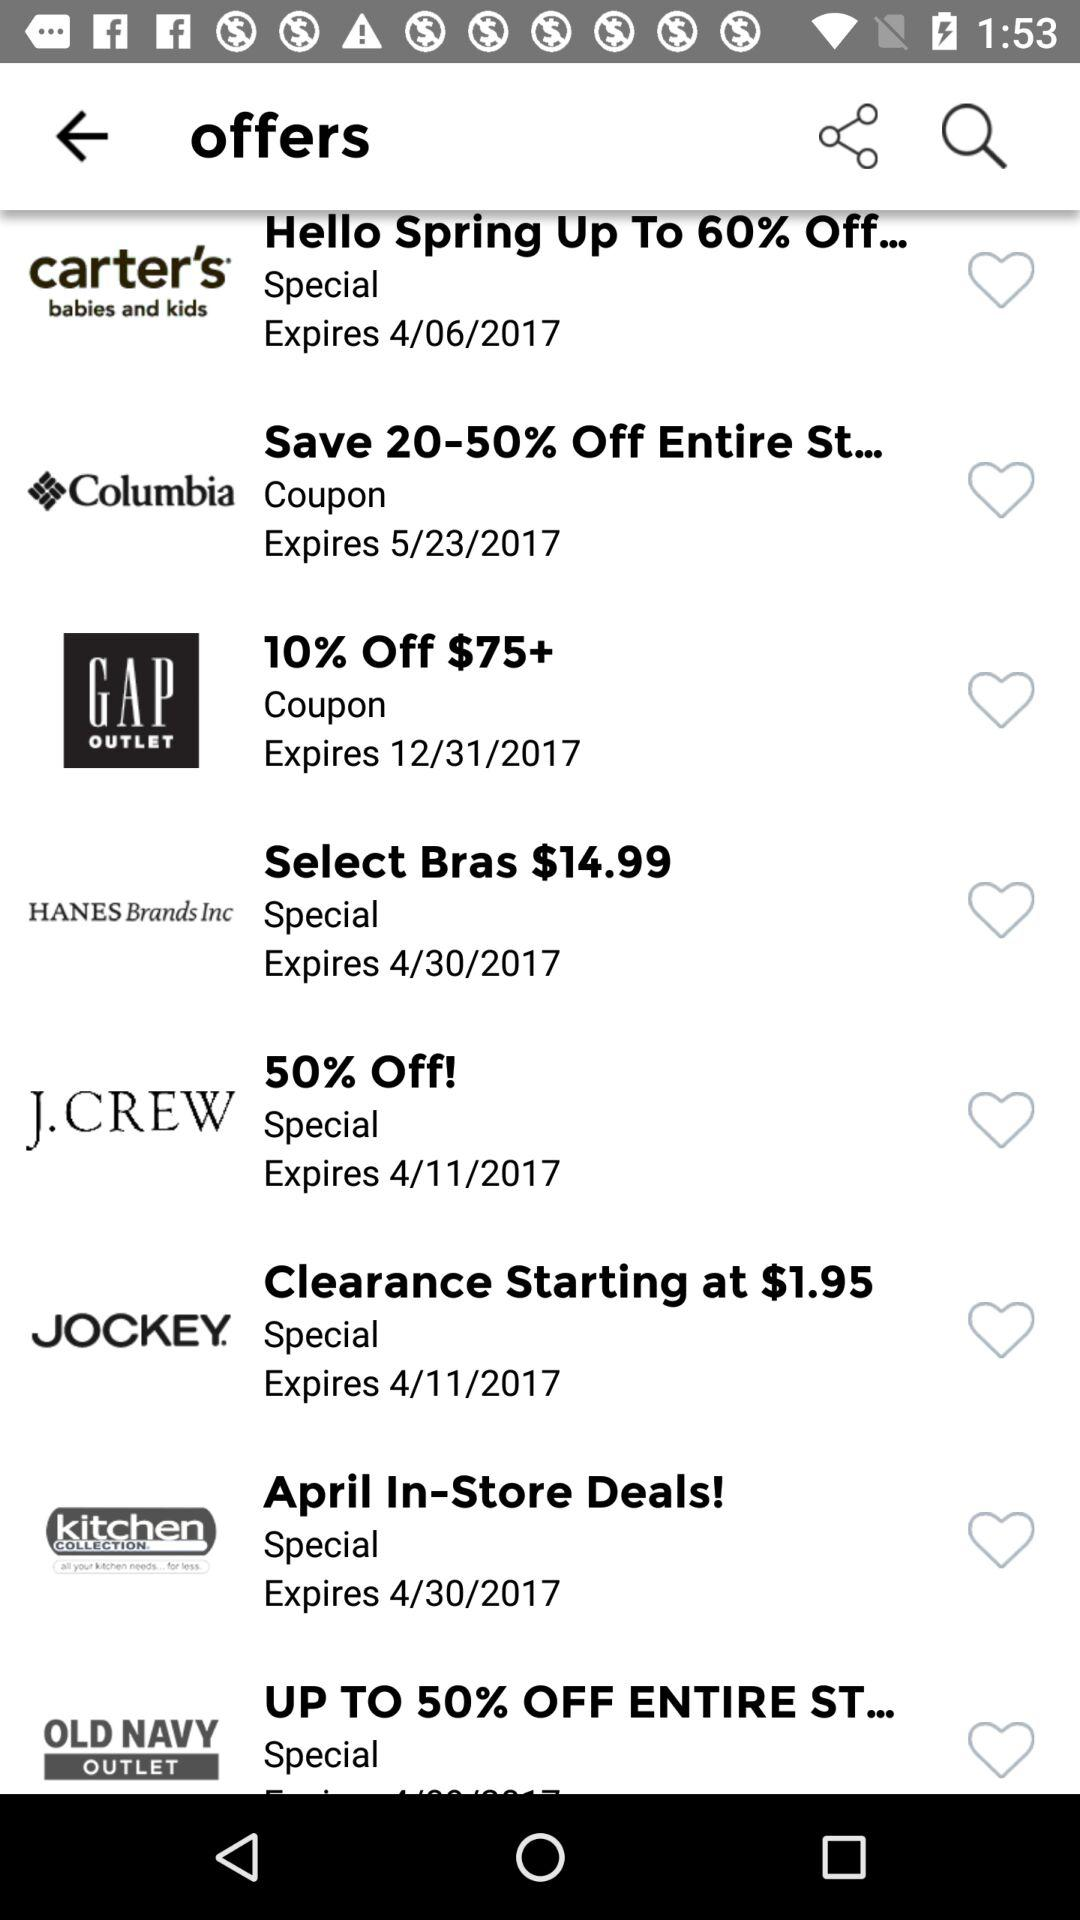What is the expiry date of the J.Crew coupon? The expiry date is 4/11/2017. 